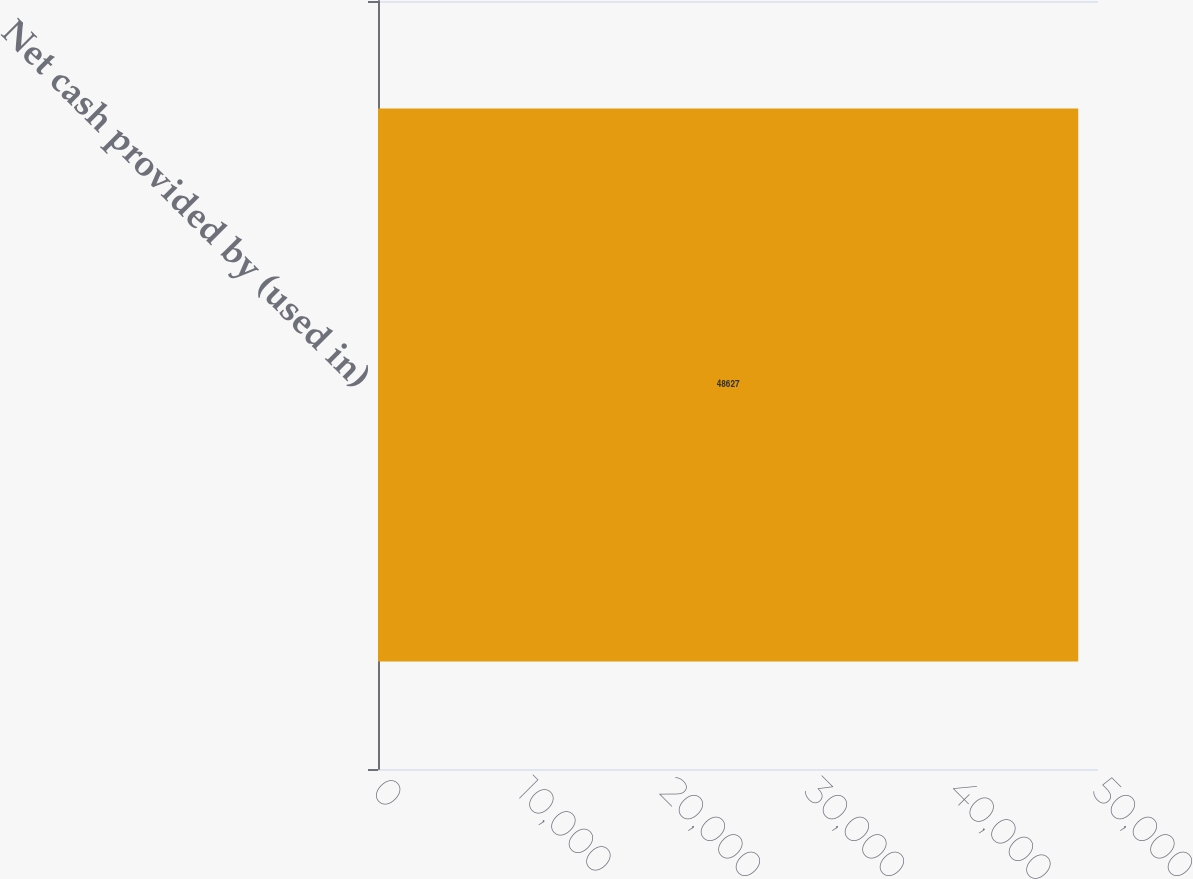Convert chart. <chart><loc_0><loc_0><loc_500><loc_500><bar_chart><fcel>Net cash provided by (used in)<nl><fcel>48627<nl></chart> 